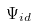<formula> <loc_0><loc_0><loc_500><loc_500>\Psi _ { i d }</formula> 